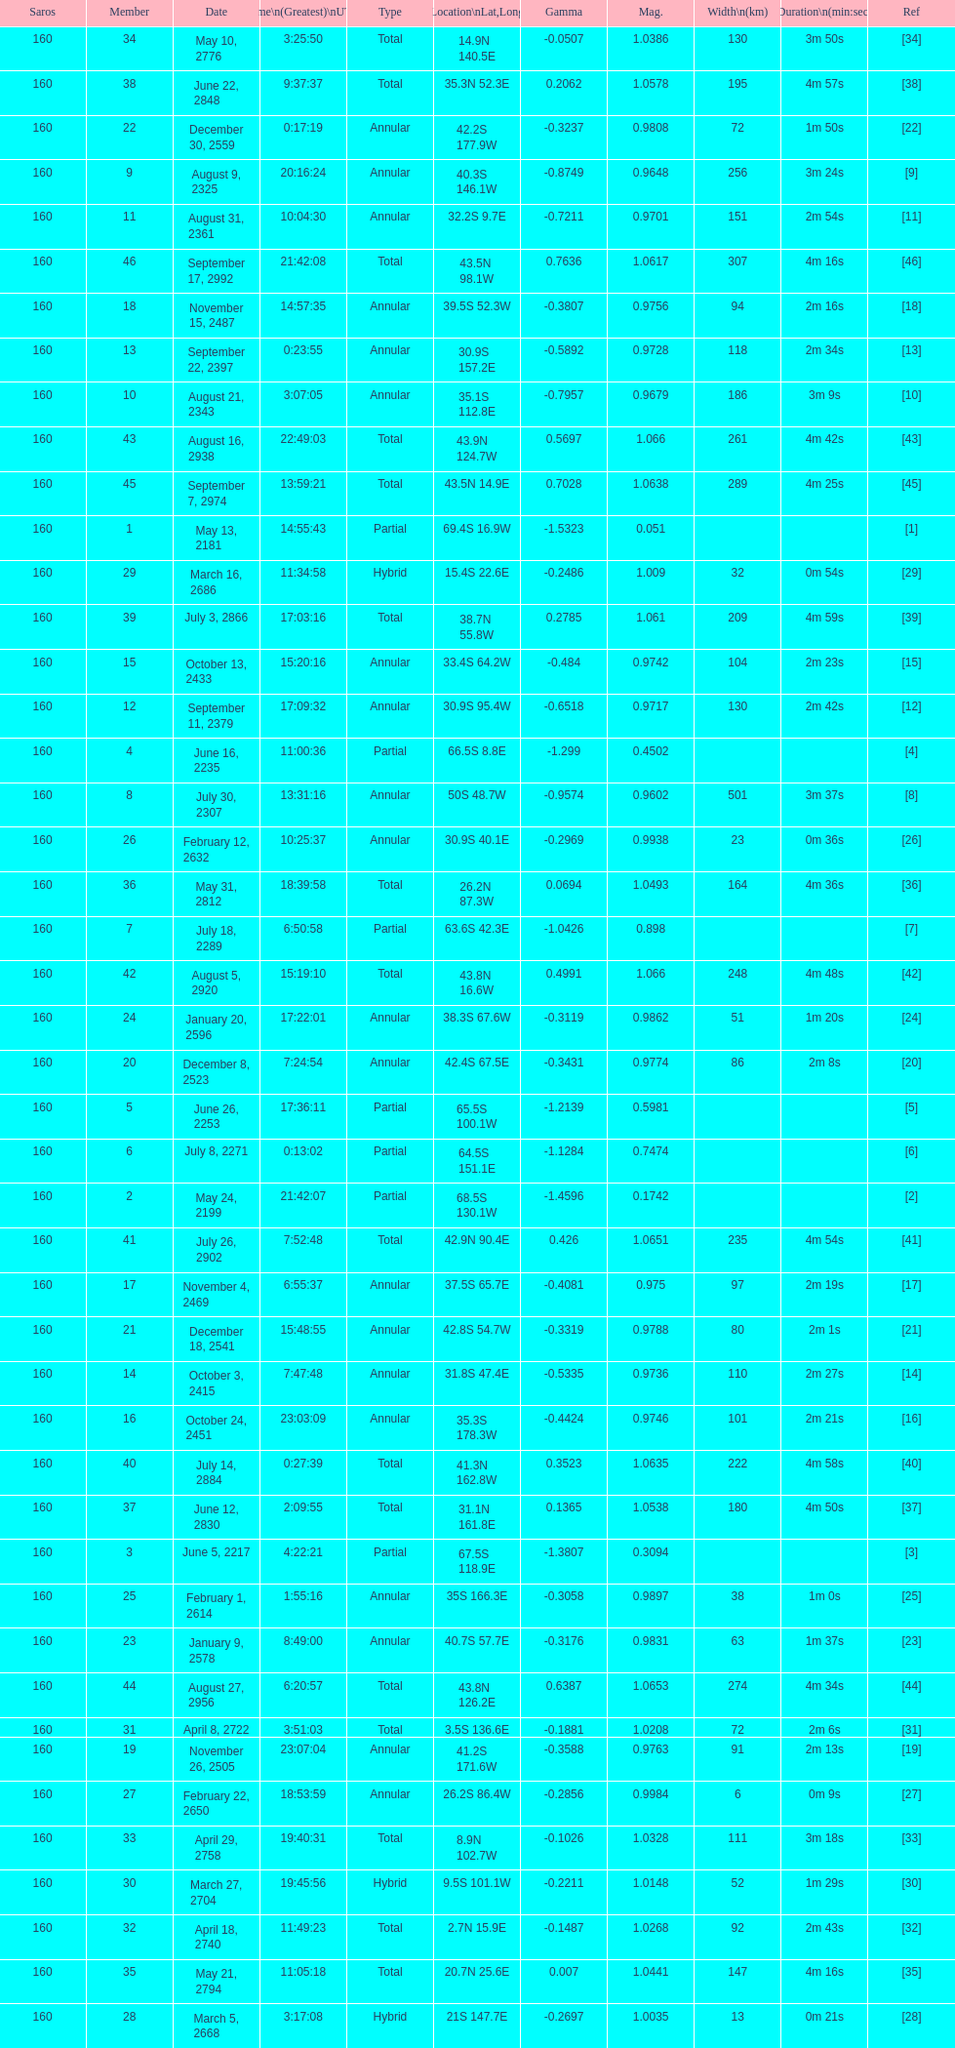How long did 18 last? 2m 16s. Could you parse the entire table as a dict? {'header': ['Saros', 'Member', 'Date', 'Time\\n(Greatest)\\nUTC', 'Type', 'Location\\nLat,Long', 'Gamma', 'Mag.', 'Width\\n(km)', 'Duration\\n(min:sec)', 'Ref'], 'rows': [['160', '34', 'May 10, 2776', '3:25:50', 'Total', '14.9N 140.5E', '-0.0507', '1.0386', '130', '3m 50s', '[34]'], ['160', '38', 'June 22, 2848', '9:37:37', 'Total', '35.3N 52.3E', '0.2062', '1.0578', '195', '4m 57s', '[38]'], ['160', '22', 'December 30, 2559', '0:17:19', 'Annular', '42.2S 177.9W', '-0.3237', '0.9808', '72', '1m 50s', '[22]'], ['160', '9', 'August 9, 2325', '20:16:24', 'Annular', '40.3S 146.1W', '-0.8749', '0.9648', '256', '3m 24s', '[9]'], ['160', '11', 'August 31, 2361', '10:04:30', 'Annular', '32.2S 9.7E', '-0.7211', '0.9701', '151', '2m 54s', '[11]'], ['160', '46', 'September 17, 2992', '21:42:08', 'Total', '43.5N 98.1W', '0.7636', '1.0617', '307', '4m 16s', '[46]'], ['160', '18', 'November 15, 2487', '14:57:35', 'Annular', '39.5S 52.3W', '-0.3807', '0.9756', '94', '2m 16s', '[18]'], ['160', '13', 'September 22, 2397', '0:23:55', 'Annular', '30.9S 157.2E', '-0.5892', '0.9728', '118', '2m 34s', '[13]'], ['160', '10', 'August 21, 2343', '3:07:05', 'Annular', '35.1S 112.8E', '-0.7957', '0.9679', '186', '3m 9s', '[10]'], ['160', '43', 'August 16, 2938', '22:49:03', 'Total', '43.9N 124.7W', '0.5697', '1.066', '261', '4m 42s', '[43]'], ['160', '45', 'September 7, 2974', '13:59:21', 'Total', '43.5N 14.9E', '0.7028', '1.0638', '289', '4m 25s', '[45]'], ['160', '1', 'May 13, 2181', '14:55:43', 'Partial', '69.4S 16.9W', '-1.5323', '0.051', '', '', '[1]'], ['160', '29', 'March 16, 2686', '11:34:58', 'Hybrid', '15.4S 22.6E', '-0.2486', '1.009', '32', '0m 54s', '[29]'], ['160', '39', 'July 3, 2866', '17:03:16', 'Total', '38.7N 55.8W', '0.2785', '1.061', '209', '4m 59s', '[39]'], ['160', '15', 'October 13, 2433', '15:20:16', 'Annular', '33.4S 64.2W', '-0.484', '0.9742', '104', '2m 23s', '[15]'], ['160', '12', 'September 11, 2379', '17:09:32', 'Annular', '30.9S 95.4W', '-0.6518', '0.9717', '130', '2m 42s', '[12]'], ['160', '4', 'June 16, 2235', '11:00:36', 'Partial', '66.5S 8.8E', '-1.299', '0.4502', '', '', '[4]'], ['160', '8', 'July 30, 2307', '13:31:16', 'Annular', '50S 48.7W', '-0.9574', '0.9602', '501', '3m 37s', '[8]'], ['160', '26', 'February 12, 2632', '10:25:37', 'Annular', '30.9S 40.1E', '-0.2969', '0.9938', '23', '0m 36s', '[26]'], ['160', '36', 'May 31, 2812', '18:39:58', 'Total', '26.2N 87.3W', '0.0694', '1.0493', '164', '4m 36s', '[36]'], ['160', '7', 'July 18, 2289', '6:50:58', 'Partial', '63.6S 42.3E', '-1.0426', '0.898', '', '', '[7]'], ['160', '42', 'August 5, 2920', '15:19:10', 'Total', '43.8N 16.6W', '0.4991', '1.066', '248', '4m 48s', '[42]'], ['160', '24', 'January 20, 2596', '17:22:01', 'Annular', '38.3S 67.6W', '-0.3119', '0.9862', '51', '1m 20s', '[24]'], ['160', '20', 'December 8, 2523', '7:24:54', 'Annular', '42.4S 67.5E', '-0.3431', '0.9774', '86', '2m 8s', '[20]'], ['160', '5', 'June 26, 2253', '17:36:11', 'Partial', '65.5S 100.1W', '-1.2139', '0.5981', '', '', '[5]'], ['160', '6', 'July 8, 2271', '0:13:02', 'Partial', '64.5S 151.1E', '-1.1284', '0.7474', '', '', '[6]'], ['160', '2', 'May 24, 2199', '21:42:07', 'Partial', '68.5S 130.1W', '-1.4596', '0.1742', '', '', '[2]'], ['160', '41', 'July 26, 2902', '7:52:48', 'Total', '42.9N 90.4E', '0.426', '1.0651', '235', '4m 54s', '[41]'], ['160', '17', 'November 4, 2469', '6:55:37', 'Annular', '37.5S 65.7E', '-0.4081', '0.975', '97', '2m 19s', '[17]'], ['160', '21', 'December 18, 2541', '15:48:55', 'Annular', '42.8S 54.7W', '-0.3319', '0.9788', '80', '2m 1s', '[21]'], ['160', '14', 'October 3, 2415', '7:47:48', 'Annular', '31.8S 47.4E', '-0.5335', '0.9736', '110', '2m 27s', '[14]'], ['160', '16', 'October 24, 2451', '23:03:09', 'Annular', '35.3S 178.3W', '-0.4424', '0.9746', '101', '2m 21s', '[16]'], ['160', '40', 'July 14, 2884', '0:27:39', 'Total', '41.3N 162.8W', '0.3523', '1.0635', '222', '4m 58s', '[40]'], ['160', '37', 'June 12, 2830', '2:09:55', 'Total', '31.1N 161.8E', '0.1365', '1.0538', '180', '4m 50s', '[37]'], ['160', '3', 'June 5, 2217', '4:22:21', 'Partial', '67.5S 118.9E', '-1.3807', '0.3094', '', '', '[3]'], ['160', '25', 'February 1, 2614', '1:55:16', 'Annular', '35S 166.3E', '-0.3058', '0.9897', '38', '1m 0s', '[25]'], ['160', '23', 'January 9, 2578', '8:49:00', 'Annular', '40.7S 57.7E', '-0.3176', '0.9831', '63', '1m 37s', '[23]'], ['160', '44', 'August 27, 2956', '6:20:57', 'Total', '43.8N 126.2E', '0.6387', '1.0653', '274', '4m 34s', '[44]'], ['160', '31', 'April 8, 2722', '3:51:03', 'Total', '3.5S 136.6E', '-0.1881', '1.0208', '72', '2m 6s', '[31]'], ['160', '19', 'November 26, 2505', '23:07:04', 'Annular', '41.2S 171.6W', '-0.3588', '0.9763', '91', '2m 13s', '[19]'], ['160', '27', 'February 22, 2650', '18:53:59', 'Annular', '26.2S 86.4W', '-0.2856', '0.9984', '6', '0m 9s', '[27]'], ['160', '33', 'April 29, 2758', '19:40:31', 'Total', '8.9N 102.7W', '-0.1026', '1.0328', '111', '3m 18s', '[33]'], ['160', '30', 'March 27, 2704', '19:45:56', 'Hybrid', '9.5S 101.1W', '-0.2211', '1.0148', '52', '1m 29s', '[30]'], ['160', '32', 'April 18, 2740', '11:49:23', 'Total', '2.7N 15.9E', '-0.1487', '1.0268', '92', '2m 43s', '[32]'], ['160', '35', 'May 21, 2794', '11:05:18', 'Total', '20.7N 25.6E', '0.007', '1.0441', '147', '4m 16s', '[35]'], ['160', '28', 'March 5, 2668', '3:17:08', 'Hybrid', '21S 147.7E', '-0.2697', '1.0035', '13', '0m 21s', '[28]']]} 